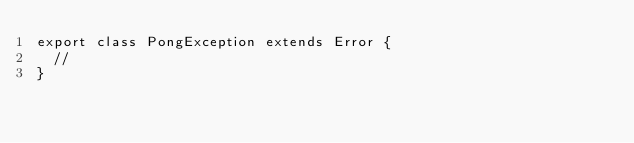<code> <loc_0><loc_0><loc_500><loc_500><_TypeScript_>export class PongException extends Error {
  //
}
</code> 